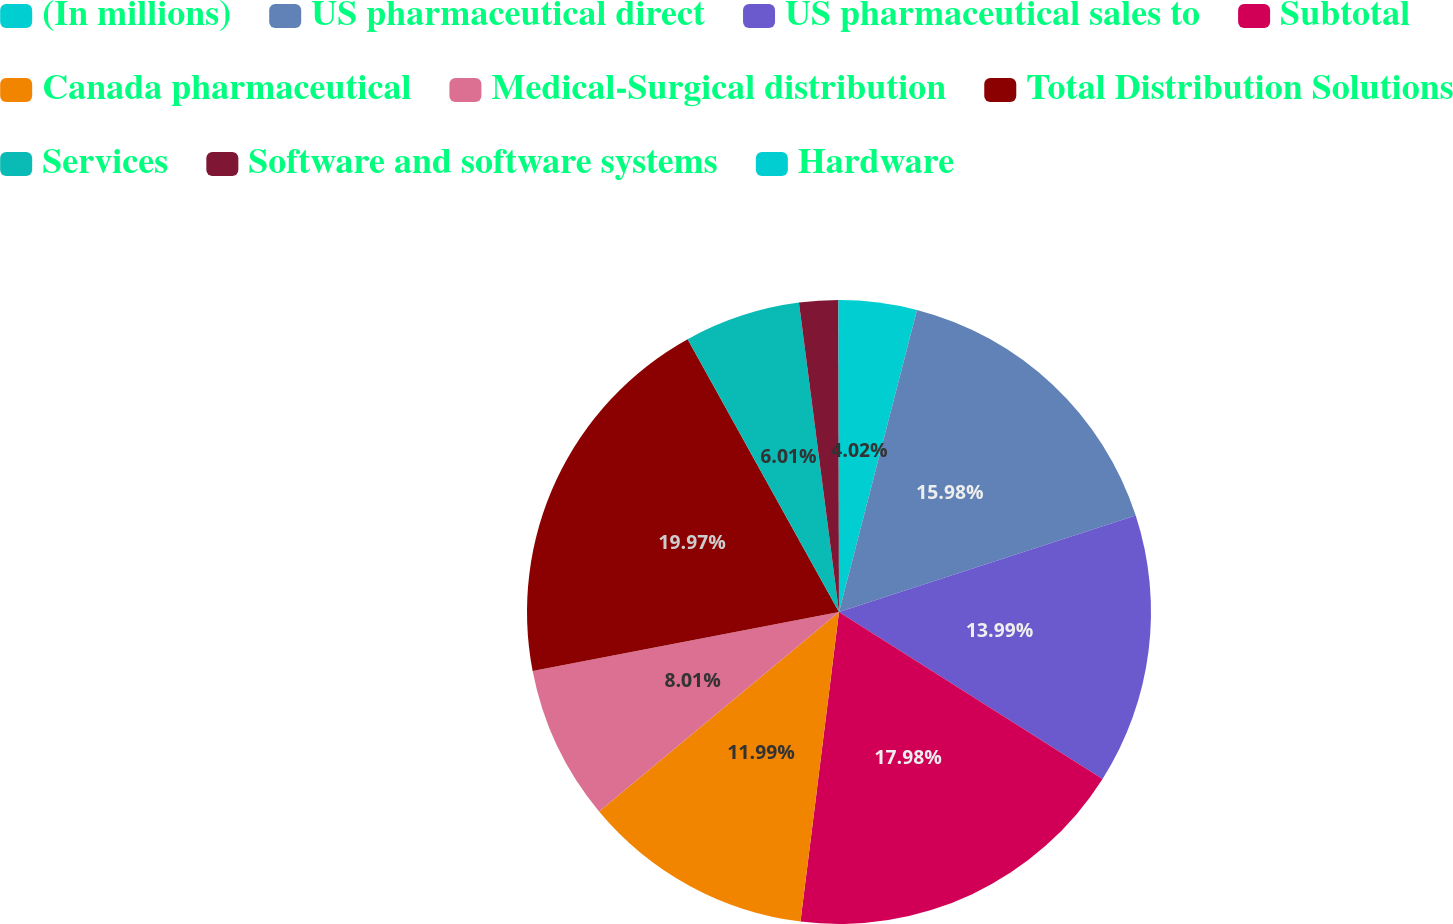Convert chart to OTSL. <chart><loc_0><loc_0><loc_500><loc_500><pie_chart><fcel>(In millions)<fcel>US pharmaceutical direct<fcel>US pharmaceutical sales to<fcel>Subtotal<fcel>Canada pharmaceutical<fcel>Medical-Surgical distribution<fcel>Total Distribution Solutions<fcel>Services<fcel>Software and software systems<fcel>Hardware<nl><fcel>4.02%<fcel>15.98%<fcel>13.99%<fcel>17.98%<fcel>11.99%<fcel>8.01%<fcel>19.97%<fcel>6.01%<fcel>2.02%<fcel>0.03%<nl></chart> 